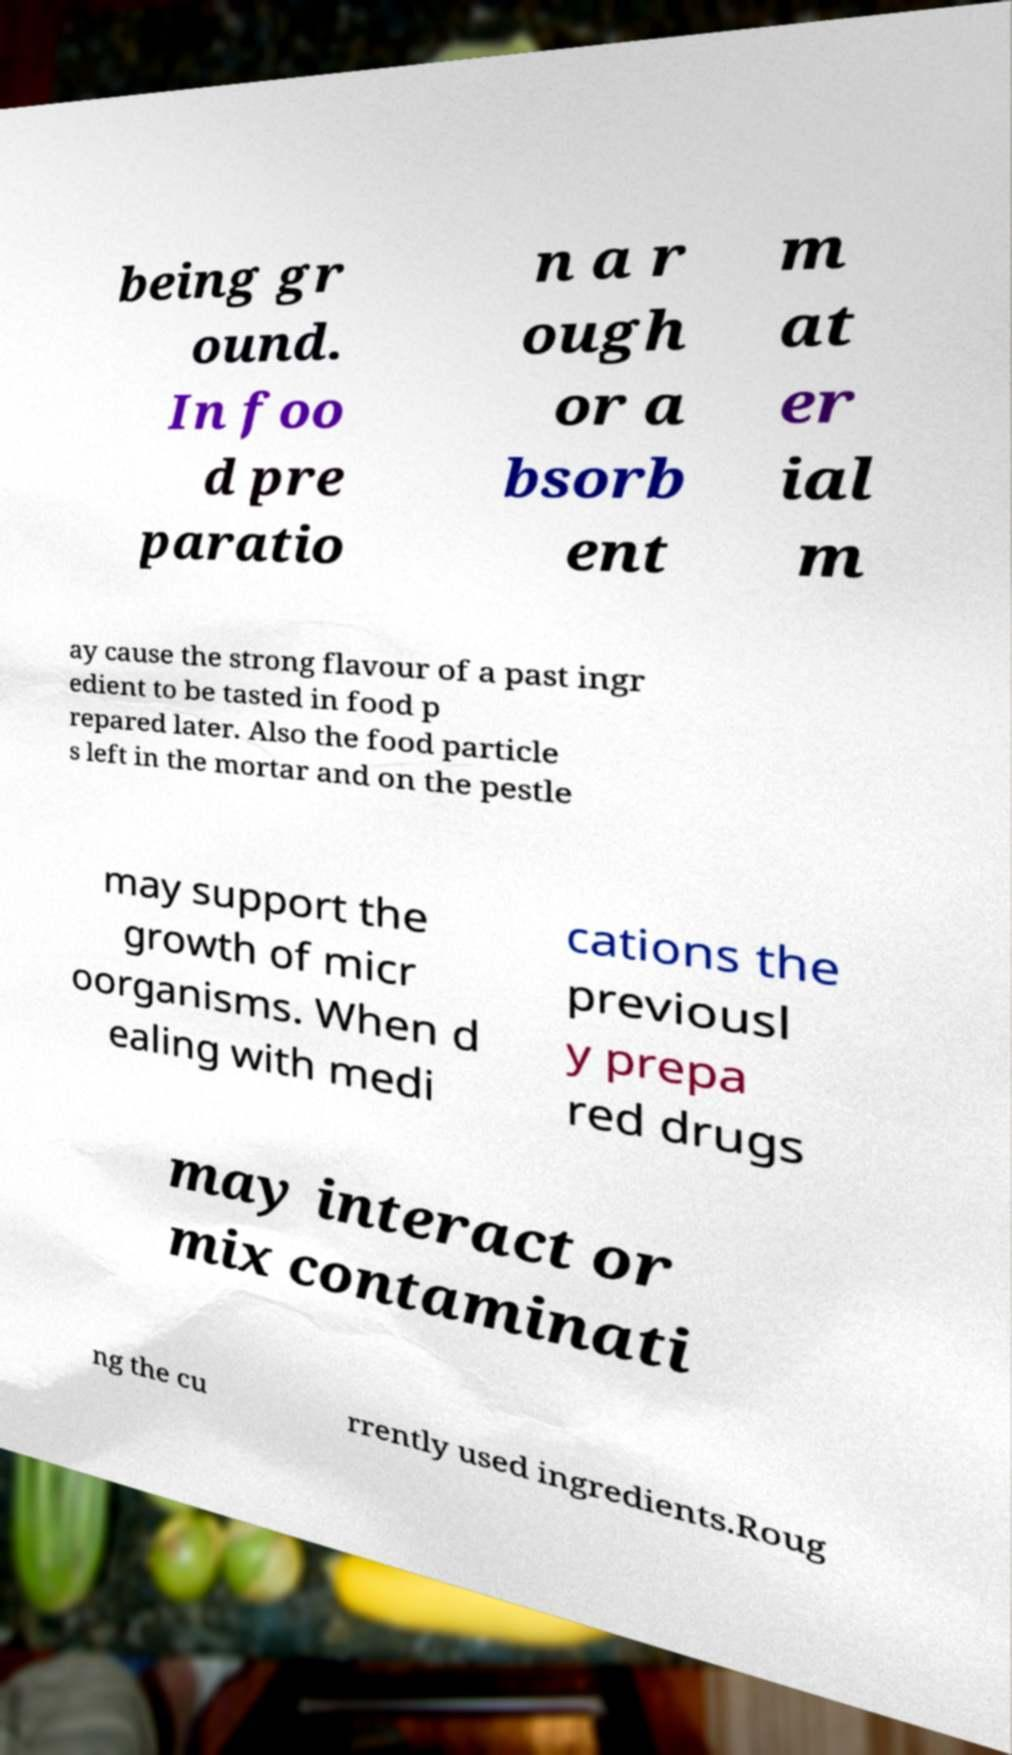Please identify and transcribe the text found in this image. being gr ound. In foo d pre paratio n a r ough or a bsorb ent m at er ial m ay cause the strong flavour of a past ingr edient to be tasted in food p repared later. Also the food particle s left in the mortar and on the pestle may support the growth of micr oorganisms. When d ealing with medi cations the previousl y prepa red drugs may interact or mix contaminati ng the cu rrently used ingredients.Roug 